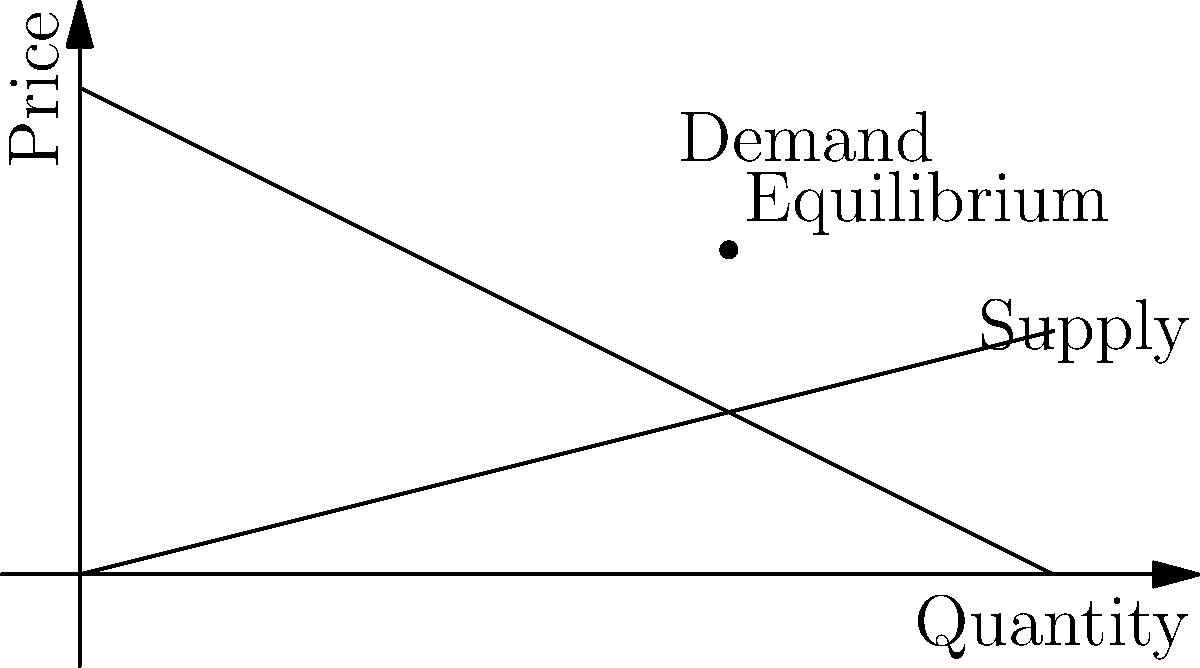As a lottery ticket vendor, you want to maximize your revenue. Given the supply and demand curves for lottery tickets shown in the graph, where the demand function is $P = 100 - 0.5Q$ and the supply function is $P = 0.25Q$, find the optimal price and quantity that will maximize your revenue. To find the optimal price and quantity, we need to follow these steps:

1) First, find the equilibrium point by equating supply and demand:
   $100 - 0.5Q = 0.25Q$
   $100 = 0.75Q$
   $Q = 133.33$

   Substitute this into either equation to find P:
   $P = 100 - 0.5(133.33) = 66.67$

2) The revenue function is $R = PQ$. Substitute the demand function for P:
   $R = (100 - 0.5Q)Q = 100Q - 0.5Q^2$

3) To maximize revenue, find where $\frac{dR}{dQ} = 0$:
   $\frac{dR}{dQ} = 100 - Q = 0$
   $Q = 100$

4) Substitute this Q back into the demand function to find P:
   $P = 100 - 0.5(100) = 50$

5) Check the second derivative to confirm this is a maximum:
   $\frac{d^2R}{dQ^2} = -1 < 0$, confirming a maximum.

Therefore, the optimal quantity is 100 tickets, and the optimal price is $50 per ticket.
Answer: Optimal price: $50; Optimal quantity: 100 tickets 